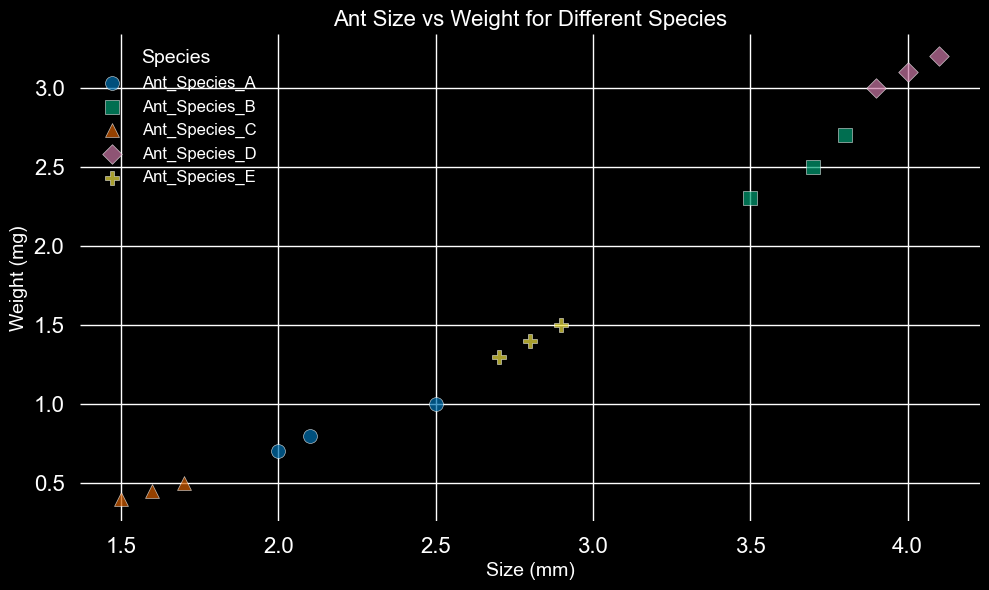What species has the smallest ants by size? Look at the scatter plot and observe that the smallest sizes are around 1.5 mm. These sizes correspond to Ant Species C.
Answer: Ant Species C Which species shows the highest weight among the ants? Inspect the scatter plot and identify the highest weight, which is around 3.2 mg. This corresponds to Ant Species D.
Answer: Ant Species D Do ant species with larger sizes generally weigh more? Notice the trend in the scatter plot: as the size of the ants increases (moving right on the x-axis), the weight also tends to increase (moving up on the y-axis). This indicates a positive correlation between size and weight.
Answer: Yes Between Ant Species A and Ant Species B, which one has a wider range of sizes? Measure the range of sizes for both species by subtracting the smallest size from the largest size within each species. The sizes for Species A range from 2.0 to 2.5 mm (0.5 mm range). For Species B, sizes range from 3.5 to 3.8 mm (0.3 mm range). Therefore, Ant Species A has a wider range of sizes.
Answer: Ant Species A What's the average weight of Ant Species E? Calculate the average weight of Ant Species E by summing the weights (1.4 + 1.5 + 1.3 = 4.2 mg) and dividing by the number of data points (3), which results in 4.2/3 = 1.4 mg.
Answer: 1.4 mg How does the size of Ant Species C compare to that of Ant Species D? Compare the sizes of the two species by inspecting the scatter plot. Ant Species C has sizes around 1.5 - 1.7 mm, while Ant Species D has sizes around 3.9 - 4.1 mm. Clearly, Ant Species D is significantly larger than Ant Species C.
Answer: Species D is larger Which species has the smallest difference between the smallest and largest weight measurements? Calculate the weight range for each species, then identify the species with the smallest range. The ranges are:
- A: 1.0 - 0.7 = 0.3 mg
- B: 2.7 - 2.3 = 0.4 mg
- C: 0.5 - 0.4 = 0.1 mg
- D: 3.2 - 3.0 = 0.2 mg
- E: 1.5 - 1.3 = 0.2 mg
Species C has the smallest weight range of just 0.1 mg.
Answer: Ant Species C Is there any species with no overlapping in sizes with other species? Examine the scatter plot to see if the sizes of any species do not overlap with any other species. Ant Species C (1.5 - 1.7 mm) and Ant Species D (3.9 - 4.1 mm) have size ranges that do not overlap with any other species.
Answer: Species C and D 